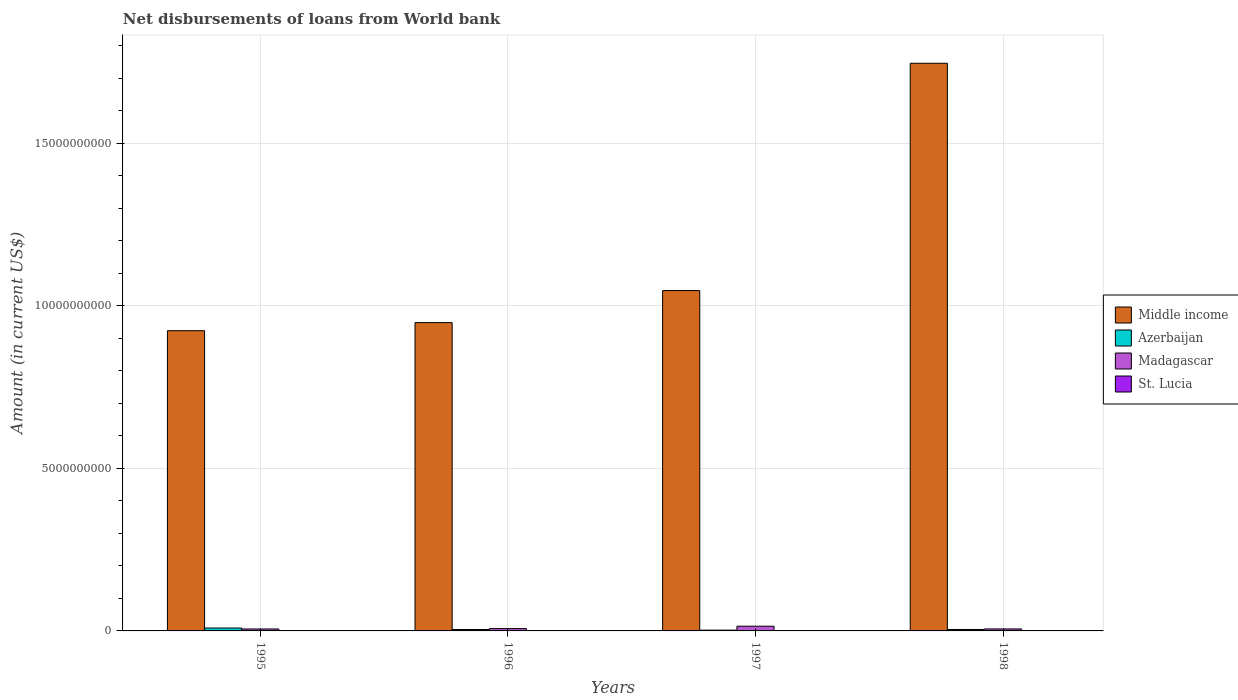How many different coloured bars are there?
Your response must be concise. 4. Are the number of bars on each tick of the X-axis equal?
Provide a short and direct response. Yes. What is the amount of loan disbursed from World Bank in St. Lucia in 1997?
Make the answer very short. 2.16e+06. Across all years, what is the maximum amount of loan disbursed from World Bank in Madagascar?
Offer a very short reply. 1.45e+08. Across all years, what is the minimum amount of loan disbursed from World Bank in Azerbaijan?
Provide a succinct answer. 2.45e+07. What is the total amount of loan disbursed from World Bank in Madagascar in the graph?
Keep it short and to the point. 3.39e+08. What is the difference between the amount of loan disbursed from World Bank in Middle income in 1996 and that in 1998?
Your answer should be compact. -7.98e+09. What is the difference between the amount of loan disbursed from World Bank in Madagascar in 1997 and the amount of loan disbursed from World Bank in St. Lucia in 1996?
Your answer should be compact. 1.37e+08. What is the average amount of loan disbursed from World Bank in Azerbaijan per year?
Your answer should be very brief. 5.04e+07. In the year 1997, what is the difference between the amount of loan disbursed from World Bank in Azerbaijan and amount of loan disbursed from World Bank in St. Lucia?
Provide a short and direct response. 2.23e+07. In how many years, is the amount of loan disbursed from World Bank in Azerbaijan greater than 14000000000 US$?
Ensure brevity in your answer.  0. What is the ratio of the amount of loan disbursed from World Bank in Madagascar in 1995 to that in 1997?
Your response must be concise. 0.41. Is the difference between the amount of loan disbursed from World Bank in Azerbaijan in 1996 and 1997 greater than the difference between the amount of loan disbursed from World Bank in St. Lucia in 1996 and 1997?
Provide a succinct answer. Yes. What is the difference between the highest and the second highest amount of loan disbursed from World Bank in St. Lucia?
Give a very brief answer. 2.10e+06. What is the difference between the highest and the lowest amount of loan disbursed from World Bank in Azerbaijan?
Provide a succinct answer. 6.50e+07. In how many years, is the amount of loan disbursed from World Bank in Madagascar greater than the average amount of loan disbursed from World Bank in Madagascar taken over all years?
Give a very brief answer. 1. What does the 2nd bar from the left in 1998 represents?
Make the answer very short. Azerbaijan. What does the 2nd bar from the right in 1998 represents?
Your response must be concise. Madagascar. How many bars are there?
Ensure brevity in your answer.  16. Are all the bars in the graph horizontal?
Offer a terse response. No. How many years are there in the graph?
Your answer should be compact. 4. Does the graph contain grids?
Your answer should be compact. Yes. How are the legend labels stacked?
Offer a terse response. Vertical. What is the title of the graph?
Provide a succinct answer. Net disbursements of loans from World bank. What is the label or title of the X-axis?
Provide a short and direct response. Years. What is the Amount (in current US$) of Middle income in 1995?
Provide a succinct answer. 9.23e+09. What is the Amount (in current US$) in Azerbaijan in 1995?
Make the answer very short. 8.95e+07. What is the Amount (in current US$) in Madagascar in 1995?
Offer a terse response. 5.99e+07. What is the Amount (in current US$) of St. Lucia in 1995?
Your answer should be compact. 6.63e+06. What is the Amount (in current US$) in Middle income in 1996?
Your answer should be very brief. 9.48e+09. What is the Amount (in current US$) in Azerbaijan in 1996?
Offer a terse response. 4.35e+07. What is the Amount (in current US$) of Madagascar in 1996?
Offer a very short reply. 7.19e+07. What is the Amount (in current US$) in St. Lucia in 1996?
Make the answer very short. 8.72e+06. What is the Amount (in current US$) in Middle income in 1997?
Provide a short and direct response. 1.05e+1. What is the Amount (in current US$) of Azerbaijan in 1997?
Offer a very short reply. 2.45e+07. What is the Amount (in current US$) in Madagascar in 1997?
Provide a short and direct response. 1.45e+08. What is the Amount (in current US$) in St. Lucia in 1997?
Make the answer very short. 2.16e+06. What is the Amount (in current US$) in Middle income in 1998?
Your response must be concise. 1.75e+1. What is the Amount (in current US$) of Azerbaijan in 1998?
Your response must be concise. 4.41e+07. What is the Amount (in current US$) in Madagascar in 1998?
Keep it short and to the point. 6.14e+07. What is the Amount (in current US$) in St. Lucia in 1998?
Your response must be concise. 5.71e+06. Across all years, what is the maximum Amount (in current US$) of Middle income?
Make the answer very short. 1.75e+1. Across all years, what is the maximum Amount (in current US$) of Azerbaijan?
Provide a succinct answer. 8.95e+07. Across all years, what is the maximum Amount (in current US$) in Madagascar?
Provide a succinct answer. 1.45e+08. Across all years, what is the maximum Amount (in current US$) of St. Lucia?
Offer a very short reply. 8.72e+06. Across all years, what is the minimum Amount (in current US$) in Middle income?
Your answer should be very brief. 9.23e+09. Across all years, what is the minimum Amount (in current US$) of Azerbaijan?
Make the answer very short. 2.45e+07. Across all years, what is the minimum Amount (in current US$) of Madagascar?
Provide a succinct answer. 5.99e+07. Across all years, what is the minimum Amount (in current US$) of St. Lucia?
Offer a very short reply. 2.16e+06. What is the total Amount (in current US$) in Middle income in the graph?
Offer a very short reply. 4.66e+1. What is the total Amount (in current US$) in Azerbaijan in the graph?
Your answer should be compact. 2.02e+08. What is the total Amount (in current US$) of Madagascar in the graph?
Give a very brief answer. 3.39e+08. What is the total Amount (in current US$) in St. Lucia in the graph?
Ensure brevity in your answer.  2.32e+07. What is the difference between the Amount (in current US$) of Middle income in 1995 and that in 1996?
Ensure brevity in your answer.  -2.48e+08. What is the difference between the Amount (in current US$) in Azerbaijan in 1995 and that in 1996?
Make the answer very short. 4.60e+07. What is the difference between the Amount (in current US$) of Madagascar in 1995 and that in 1996?
Offer a very short reply. -1.20e+07. What is the difference between the Amount (in current US$) of St. Lucia in 1995 and that in 1996?
Your answer should be very brief. -2.10e+06. What is the difference between the Amount (in current US$) in Middle income in 1995 and that in 1997?
Provide a succinct answer. -1.23e+09. What is the difference between the Amount (in current US$) in Azerbaijan in 1995 and that in 1997?
Provide a succinct answer. 6.50e+07. What is the difference between the Amount (in current US$) in Madagascar in 1995 and that in 1997?
Your answer should be very brief. -8.54e+07. What is the difference between the Amount (in current US$) of St. Lucia in 1995 and that in 1997?
Ensure brevity in your answer.  4.47e+06. What is the difference between the Amount (in current US$) of Middle income in 1995 and that in 1998?
Your response must be concise. -8.23e+09. What is the difference between the Amount (in current US$) of Azerbaijan in 1995 and that in 1998?
Make the answer very short. 4.54e+07. What is the difference between the Amount (in current US$) in Madagascar in 1995 and that in 1998?
Your response must be concise. -1.48e+06. What is the difference between the Amount (in current US$) in St. Lucia in 1995 and that in 1998?
Your answer should be very brief. 9.19e+05. What is the difference between the Amount (in current US$) of Middle income in 1996 and that in 1997?
Your response must be concise. -9.86e+08. What is the difference between the Amount (in current US$) in Azerbaijan in 1996 and that in 1997?
Your answer should be compact. 1.91e+07. What is the difference between the Amount (in current US$) of Madagascar in 1996 and that in 1997?
Keep it short and to the point. -7.34e+07. What is the difference between the Amount (in current US$) in St. Lucia in 1996 and that in 1997?
Your answer should be compact. 6.56e+06. What is the difference between the Amount (in current US$) in Middle income in 1996 and that in 1998?
Offer a very short reply. -7.98e+09. What is the difference between the Amount (in current US$) in Azerbaijan in 1996 and that in 1998?
Your response must be concise. -5.93e+05. What is the difference between the Amount (in current US$) in Madagascar in 1996 and that in 1998?
Provide a succinct answer. 1.05e+07. What is the difference between the Amount (in current US$) in St. Lucia in 1996 and that in 1998?
Provide a short and direct response. 3.02e+06. What is the difference between the Amount (in current US$) of Middle income in 1997 and that in 1998?
Offer a terse response. -6.99e+09. What is the difference between the Amount (in current US$) in Azerbaijan in 1997 and that in 1998?
Keep it short and to the point. -1.97e+07. What is the difference between the Amount (in current US$) in Madagascar in 1997 and that in 1998?
Keep it short and to the point. 8.39e+07. What is the difference between the Amount (in current US$) of St. Lucia in 1997 and that in 1998?
Give a very brief answer. -3.55e+06. What is the difference between the Amount (in current US$) of Middle income in 1995 and the Amount (in current US$) of Azerbaijan in 1996?
Provide a short and direct response. 9.19e+09. What is the difference between the Amount (in current US$) in Middle income in 1995 and the Amount (in current US$) in Madagascar in 1996?
Offer a very short reply. 9.16e+09. What is the difference between the Amount (in current US$) of Middle income in 1995 and the Amount (in current US$) of St. Lucia in 1996?
Offer a very short reply. 9.23e+09. What is the difference between the Amount (in current US$) of Azerbaijan in 1995 and the Amount (in current US$) of Madagascar in 1996?
Offer a very short reply. 1.76e+07. What is the difference between the Amount (in current US$) in Azerbaijan in 1995 and the Amount (in current US$) in St. Lucia in 1996?
Provide a succinct answer. 8.08e+07. What is the difference between the Amount (in current US$) in Madagascar in 1995 and the Amount (in current US$) in St. Lucia in 1996?
Keep it short and to the point. 5.12e+07. What is the difference between the Amount (in current US$) in Middle income in 1995 and the Amount (in current US$) in Azerbaijan in 1997?
Give a very brief answer. 9.21e+09. What is the difference between the Amount (in current US$) in Middle income in 1995 and the Amount (in current US$) in Madagascar in 1997?
Provide a short and direct response. 9.09e+09. What is the difference between the Amount (in current US$) of Middle income in 1995 and the Amount (in current US$) of St. Lucia in 1997?
Make the answer very short. 9.23e+09. What is the difference between the Amount (in current US$) in Azerbaijan in 1995 and the Amount (in current US$) in Madagascar in 1997?
Offer a very short reply. -5.58e+07. What is the difference between the Amount (in current US$) in Azerbaijan in 1995 and the Amount (in current US$) in St. Lucia in 1997?
Offer a terse response. 8.74e+07. What is the difference between the Amount (in current US$) in Madagascar in 1995 and the Amount (in current US$) in St. Lucia in 1997?
Your response must be concise. 5.78e+07. What is the difference between the Amount (in current US$) in Middle income in 1995 and the Amount (in current US$) in Azerbaijan in 1998?
Make the answer very short. 9.19e+09. What is the difference between the Amount (in current US$) of Middle income in 1995 and the Amount (in current US$) of Madagascar in 1998?
Keep it short and to the point. 9.17e+09. What is the difference between the Amount (in current US$) of Middle income in 1995 and the Amount (in current US$) of St. Lucia in 1998?
Provide a short and direct response. 9.23e+09. What is the difference between the Amount (in current US$) in Azerbaijan in 1995 and the Amount (in current US$) in Madagascar in 1998?
Offer a very short reply. 2.81e+07. What is the difference between the Amount (in current US$) in Azerbaijan in 1995 and the Amount (in current US$) in St. Lucia in 1998?
Your response must be concise. 8.38e+07. What is the difference between the Amount (in current US$) of Madagascar in 1995 and the Amount (in current US$) of St. Lucia in 1998?
Offer a terse response. 5.42e+07. What is the difference between the Amount (in current US$) in Middle income in 1996 and the Amount (in current US$) in Azerbaijan in 1997?
Give a very brief answer. 9.46e+09. What is the difference between the Amount (in current US$) of Middle income in 1996 and the Amount (in current US$) of Madagascar in 1997?
Your answer should be very brief. 9.34e+09. What is the difference between the Amount (in current US$) of Middle income in 1996 and the Amount (in current US$) of St. Lucia in 1997?
Keep it short and to the point. 9.48e+09. What is the difference between the Amount (in current US$) in Azerbaijan in 1996 and the Amount (in current US$) in Madagascar in 1997?
Provide a short and direct response. -1.02e+08. What is the difference between the Amount (in current US$) of Azerbaijan in 1996 and the Amount (in current US$) of St. Lucia in 1997?
Offer a very short reply. 4.14e+07. What is the difference between the Amount (in current US$) in Madagascar in 1996 and the Amount (in current US$) in St. Lucia in 1997?
Your response must be concise. 6.97e+07. What is the difference between the Amount (in current US$) of Middle income in 1996 and the Amount (in current US$) of Azerbaijan in 1998?
Your answer should be compact. 9.44e+09. What is the difference between the Amount (in current US$) of Middle income in 1996 and the Amount (in current US$) of Madagascar in 1998?
Offer a terse response. 9.42e+09. What is the difference between the Amount (in current US$) of Middle income in 1996 and the Amount (in current US$) of St. Lucia in 1998?
Offer a terse response. 9.48e+09. What is the difference between the Amount (in current US$) in Azerbaijan in 1996 and the Amount (in current US$) in Madagascar in 1998?
Offer a very short reply. -1.79e+07. What is the difference between the Amount (in current US$) of Azerbaijan in 1996 and the Amount (in current US$) of St. Lucia in 1998?
Provide a short and direct response. 3.78e+07. What is the difference between the Amount (in current US$) of Madagascar in 1996 and the Amount (in current US$) of St. Lucia in 1998?
Make the answer very short. 6.62e+07. What is the difference between the Amount (in current US$) in Middle income in 1997 and the Amount (in current US$) in Azerbaijan in 1998?
Keep it short and to the point. 1.04e+1. What is the difference between the Amount (in current US$) of Middle income in 1997 and the Amount (in current US$) of Madagascar in 1998?
Make the answer very short. 1.04e+1. What is the difference between the Amount (in current US$) of Middle income in 1997 and the Amount (in current US$) of St. Lucia in 1998?
Ensure brevity in your answer.  1.05e+1. What is the difference between the Amount (in current US$) in Azerbaijan in 1997 and the Amount (in current US$) in Madagascar in 1998?
Your response must be concise. -3.69e+07. What is the difference between the Amount (in current US$) of Azerbaijan in 1997 and the Amount (in current US$) of St. Lucia in 1998?
Your answer should be compact. 1.88e+07. What is the difference between the Amount (in current US$) of Madagascar in 1997 and the Amount (in current US$) of St. Lucia in 1998?
Provide a succinct answer. 1.40e+08. What is the average Amount (in current US$) of Middle income per year?
Your response must be concise. 1.17e+1. What is the average Amount (in current US$) of Azerbaijan per year?
Keep it short and to the point. 5.04e+07. What is the average Amount (in current US$) in Madagascar per year?
Your response must be concise. 8.46e+07. What is the average Amount (in current US$) of St. Lucia per year?
Give a very brief answer. 5.81e+06. In the year 1995, what is the difference between the Amount (in current US$) of Middle income and Amount (in current US$) of Azerbaijan?
Offer a terse response. 9.15e+09. In the year 1995, what is the difference between the Amount (in current US$) of Middle income and Amount (in current US$) of Madagascar?
Your answer should be compact. 9.17e+09. In the year 1995, what is the difference between the Amount (in current US$) in Middle income and Amount (in current US$) in St. Lucia?
Offer a terse response. 9.23e+09. In the year 1995, what is the difference between the Amount (in current US$) in Azerbaijan and Amount (in current US$) in Madagascar?
Provide a succinct answer. 2.96e+07. In the year 1995, what is the difference between the Amount (in current US$) in Azerbaijan and Amount (in current US$) in St. Lucia?
Make the answer very short. 8.29e+07. In the year 1995, what is the difference between the Amount (in current US$) in Madagascar and Amount (in current US$) in St. Lucia?
Ensure brevity in your answer.  5.33e+07. In the year 1996, what is the difference between the Amount (in current US$) of Middle income and Amount (in current US$) of Azerbaijan?
Your answer should be compact. 9.44e+09. In the year 1996, what is the difference between the Amount (in current US$) of Middle income and Amount (in current US$) of Madagascar?
Give a very brief answer. 9.41e+09. In the year 1996, what is the difference between the Amount (in current US$) of Middle income and Amount (in current US$) of St. Lucia?
Provide a succinct answer. 9.47e+09. In the year 1996, what is the difference between the Amount (in current US$) in Azerbaijan and Amount (in current US$) in Madagascar?
Provide a succinct answer. -2.83e+07. In the year 1996, what is the difference between the Amount (in current US$) of Azerbaijan and Amount (in current US$) of St. Lucia?
Your response must be concise. 3.48e+07. In the year 1996, what is the difference between the Amount (in current US$) of Madagascar and Amount (in current US$) of St. Lucia?
Offer a terse response. 6.32e+07. In the year 1997, what is the difference between the Amount (in current US$) of Middle income and Amount (in current US$) of Azerbaijan?
Ensure brevity in your answer.  1.04e+1. In the year 1997, what is the difference between the Amount (in current US$) of Middle income and Amount (in current US$) of Madagascar?
Offer a very short reply. 1.03e+1. In the year 1997, what is the difference between the Amount (in current US$) in Middle income and Amount (in current US$) in St. Lucia?
Keep it short and to the point. 1.05e+1. In the year 1997, what is the difference between the Amount (in current US$) of Azerbaijan and Amount (in current US$) of Madagascar?
Offer a very short reply. -1.21e+08. In the year 1997, what is the difference between the Amount (in current US$) in Azerbaijan and Amount (in current US$) in St. Lucia?
Provide a succinct answer. 2.23e+07. In the year 1997, what is the difference between the Amount (in current US$) of Madagascar and Amount (in current US$) of St. Lucia?
Offer a terse response. 1.43e+08. In the year 1998, what is the difference between the Amount (in current US$) in Middle income and Amount (in current US$) in Azerbaijan?
Your answer should be very brief. 1.74e+1. In the year 1998, what is the difference between the Amount (in current US$) of Middle income and Amount (in current US$) of Madagascar?
Give a very brief answer. 1.74e+1. In the year 1998, what is the difference between the Amount (in current US$) in Middle income and Amount (in current US$) in St. Lucia?
Offer a terse response. 1.75e+1. In the year 1998, what is the difference between the Amount (in current US$) in Azerbaijan and Amount (in current US$) in Madagascar?
Offer a terse response. -1.73e+07. In the year 1998, what is the difference between the Amount (in current US$) of Azerbaijan and Amount (in current US$) of St. Lucia?
Your answer should be very brief. 3.84e+07. In the year 1998, what is the difference between the Amount (in current US$) of Madagascar and Amount (in current US$) of St. Lucia?
Your response must be concise. 5.57e+07. What is the ratio of the Amount (in current US$) of Middle income in 1995 to that in 1996?
Offer a terse response. 0.97. What is the ratio of the Amount (in current US$) in Azerbaijan in 1995 to that in 1996?
Your answer should be very brief. 2.06. What is the ratio of the Amount (in current US$) in Madagascar in 1995 to that in 1996?
Keep it short and to the point. 0.83. What is the ratio of the Amount (in current US$) in St. Lucia in 1995 to that in 1996?
Your response must be concise. 0.76. What is the ratio of the Amount (in current US$) of Middle income in 1995 to that in 1997?
Your response must be concise. 0.88. What is the ratio of the Amount (in current US$) in Azerbaijan in 1995 to that in 1997?
Make the answer very short. 3.66. What is the ratio of the Amount (in current US$) in Madagascar in 1995 to that in 1997?
Offer a very short reply. 0.41. What is the ratio of the Amount (in current US$) in St. Lucia in 1995 to that in 1997?
Your response must be concise. 3.07. What is the ratio of the Amount (in current US$) in Middle income in 1995 to that in 1998?
Your answer should be compact. 0.53. What is the ratio of the Amount (in current US$) of Azerbaijan in 1995 to that in 1998?
Keep it short and to the point. 2.03. What is the ratio of the Amount (in current US$) of Madagascar in 1995 to that in 1998?
Offer a terse response. 0.98. What is the ratio of the Amount (in current US$) in St. Lucia in 1995 to that in 1998?
Offer a terse response. 1.16. What is the ratio of the Amount (in current US$) in Middle income in 1996 to that in 1997?
Provide a short and direct response. 0.91. What is the ratio of the Amount (in current US$) in Azerbaijan in 1996 to that in 1997?
Provide a succinct answer. 1.78. What is the ratio of the Amount (in current US$) of Madagascar in 1996 to that in 1997?
Offer a very short reply. 0.49. What is the ratio of the Amount (in current US$) in St. Lucia in 1996 to that in 1997?
Keep it short and to the point. 4.04. What is the ratio of the Amount (in current US$) in Middle income in 1996 to that in 1998?
Offer a terse response. 0.54. What is the ratio of the Amount (in current US$) in Azerbaijan in 1996 to that in 1998?
Your answer should be very brief. 0.99. What is the ratio of the Amount (in current US$) of Madagascar in 1996 to that in 1998?
Offer a terse response. 1.17. What is the ratio of the Amount (in current US$) of St. Lucia in 1996 to that in 1998?
Offer a terse response. 1.53. What is the ratio of the Amount (in current US$) of Middle income in 1997 to that in 1998?
Provide a succinct answer. 0.6. What is the ratio of the Amount (in current US$) of Azerbaijan in 1997 to that in 1998?
Your answer should be compact. 0.55. What is the ratio of the Amount (in current US$) of Madagascar in 1997 to that in 1998?
Your answer should be very brief. 2.37. What is the ratio of the Amount (in current US$) in St. Lucia in 1997 to that in 1998?
Your answer should be compact. 0.38. What is the difference between the highest and the second highest Amount (in current US$) in Middle income?
Keep it short and to the point. 6.99e+09. What is the difference between the highest and the second highest Amount (in current US$) of Azerbaijan?
Offer a terse response. 4.54e+07. What is the difference between the highest and the second highest Amount (in current US$) in Madagascar?
Your answer should be very brief. 7.34e+07. What is the difference between the highest and the second highest Amount (in current US$) in St. Lucia?
Offer a very short reply. 2.10e+06. What is the difference between the highest and the lowest Amount (in current US$) of Middle income?
Keep it short and to the point. 8.23e+09. What is the difference between the highest and the lowest Amount (in current US$) of Azerbaijan?
Give a very brief answer. 6.50e+07. What is the difference between the highest and the lowest Amount (in current US$) of Madagascar?
Keep it short and to the point. 8.54e+07. What is the difference between the highest and the lowest Amount (in current US$) in St. Lucia?
Provide a short and direct response. 6.56e+06. 